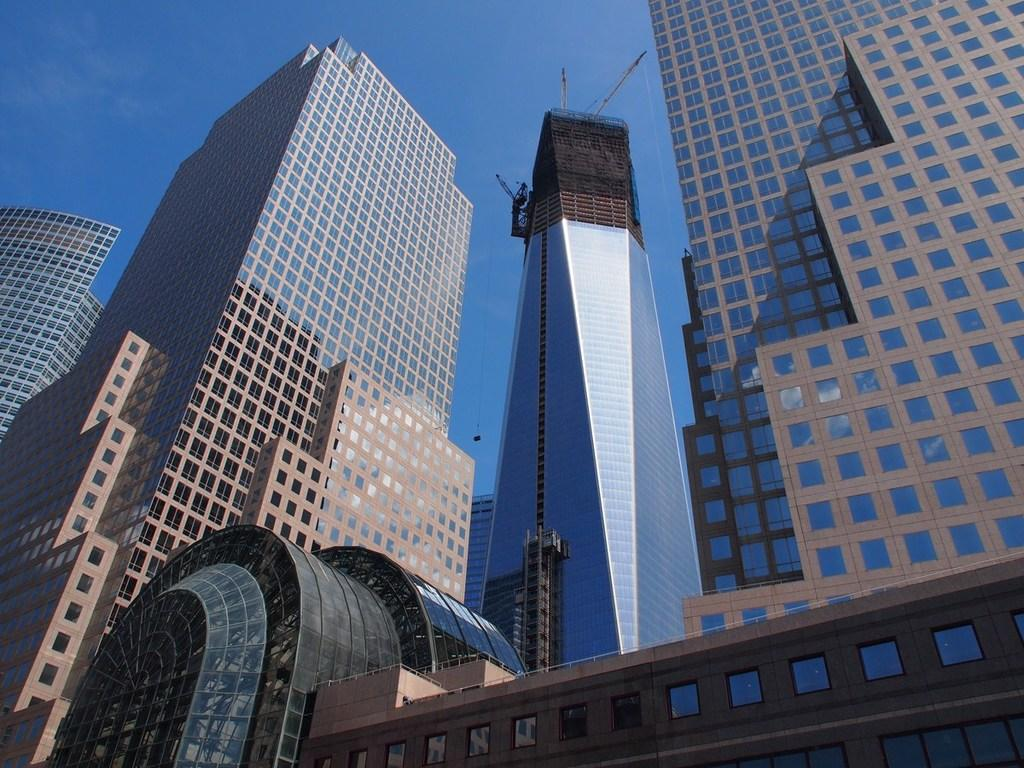What type of structures are located in the middle of the image? There are tall buildings in the middle of the image. What feature can be observed on the buildings? The buildings have glass windows. What is visible at the top of the image? The sky is visible at the top of the image. What type of support can be seen holding up the buildings in the image? There is no visible support holding up the buildings in the image; the focus is on the buildings themselves and their glass windows. 